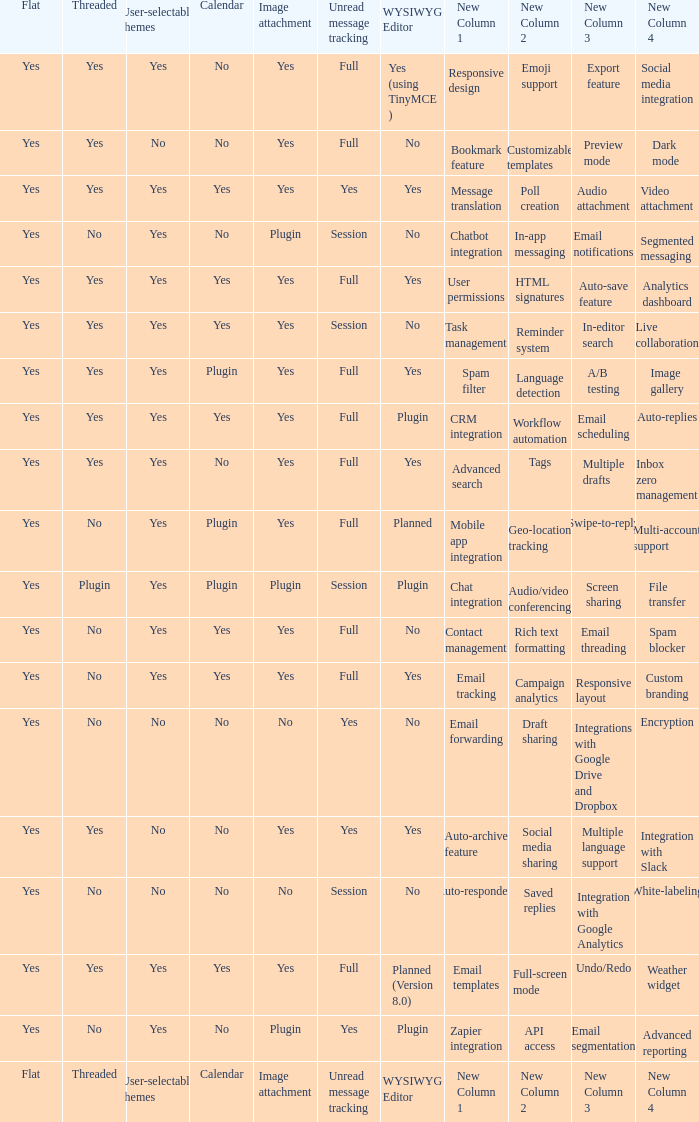Which Calendar has WYSIWYG Editor of yes and an Unread message tracking of yes? Yes, No. 